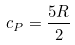<formula> <loc_0><loc_0><loc_500><loc_500>c _ { P } = \frac { 5 R } { 2 }</formula> 